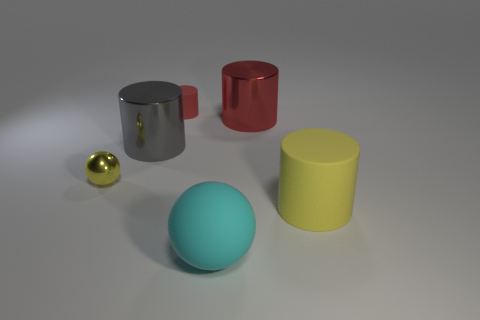How many large metal objects are the same color as the small matte cylinder?
Make the answer very short. 1. Are there any gray metallic things left of the tiny yellow metallic object?
Your response must be concise. No. Do the red metallic cylinder and the red matte cylinder have the same size?
Your answer should be very brief. No. What size is the other thing that is the same shape as the tiny yellow metallic object?
Give a very brief answer. Large. What material is the yellow thing behind the large cylinder that is in front of the small metallic thing made of?
Keep it short and to the point. Metal. Do the yellow matte thing and the large red object have the same shape?
Offer a very short reply. Yes. What number of matte objects are in front of the tiny red matte cylinder and behind the yellow rubber thing?
Your answer should be very brief. 0. Is the number of spheres that are right of the large gray object the same as the number of big gray cylinders right of the matte sphere?
Offer a very short reply. No. There is a cylinder left of the small matte thing; is its size the same as the metallic object on the left side of the gray thing?
Ensure brevity in your answer.  No. There is a object that is to the left of the big yellow rubber cylinder and in front of the small sphere; what material is it made of?
Ensure brevity in your answer.  Rubber. 